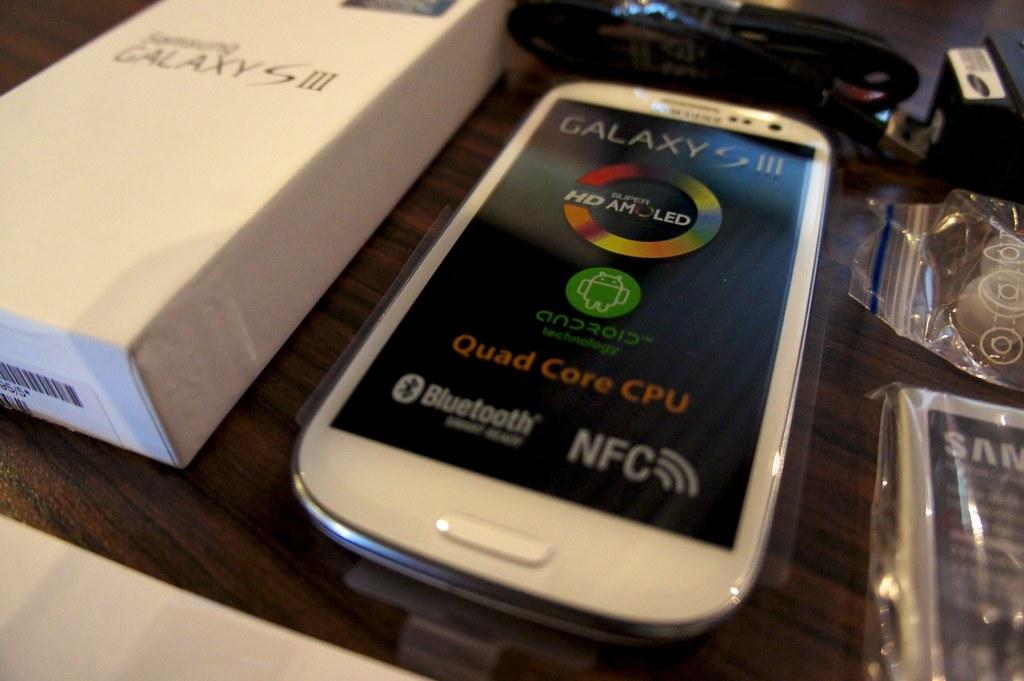What model of phone is this?
Your response must be concise. Galaxy s iii. What brand of phone is this?
Your answer should be compact. Samsung. 